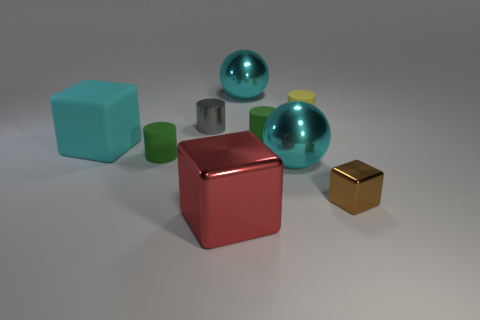Subtract all metal blocks. How many blocks are left? 1 Subtract all gray cubes. How many green cylinders are left? 2 Subtract 2 cylinders. How many cylinders are left? 2 Subtract all green cylinders. How many cylinders are left? 2 Subtract all cyan cylinders. Subtract all green balls. How many cylinders are left? 4 Add 1 small metal blocks. How many small metal blocks exist? 2 Subtract 0 purple cylinders. How many objects are left? 9 Subtract all cylinders. How many objects are left? 5 Subtract all big brown rubber things. Subtract all tiny brown metallic cubes. How many objects are left? 8 Add 2 big cyan matte cubes. How many big cyan matte cubes are left? 3 